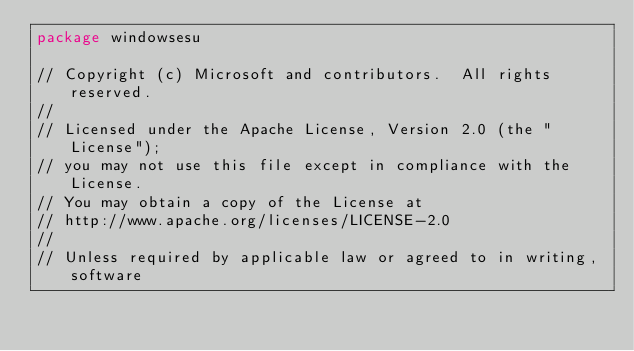Convert code to text. <code><loc_0><loc_0><loc_500><loc_500><_Go_>package windowsesu

// Copyright (c) Microsoft and contributors.  All rights reserved.
//
// Licensed under the Apache License, Version 2.0 (the "License");
// you may not use this file except in compliance with the License.
// You may obtain a copy of the License at
// http://www.apache.org/licenses/LICENSE-2.0
//
// Unless required by applicable law or agreed to in writing, software</code> 